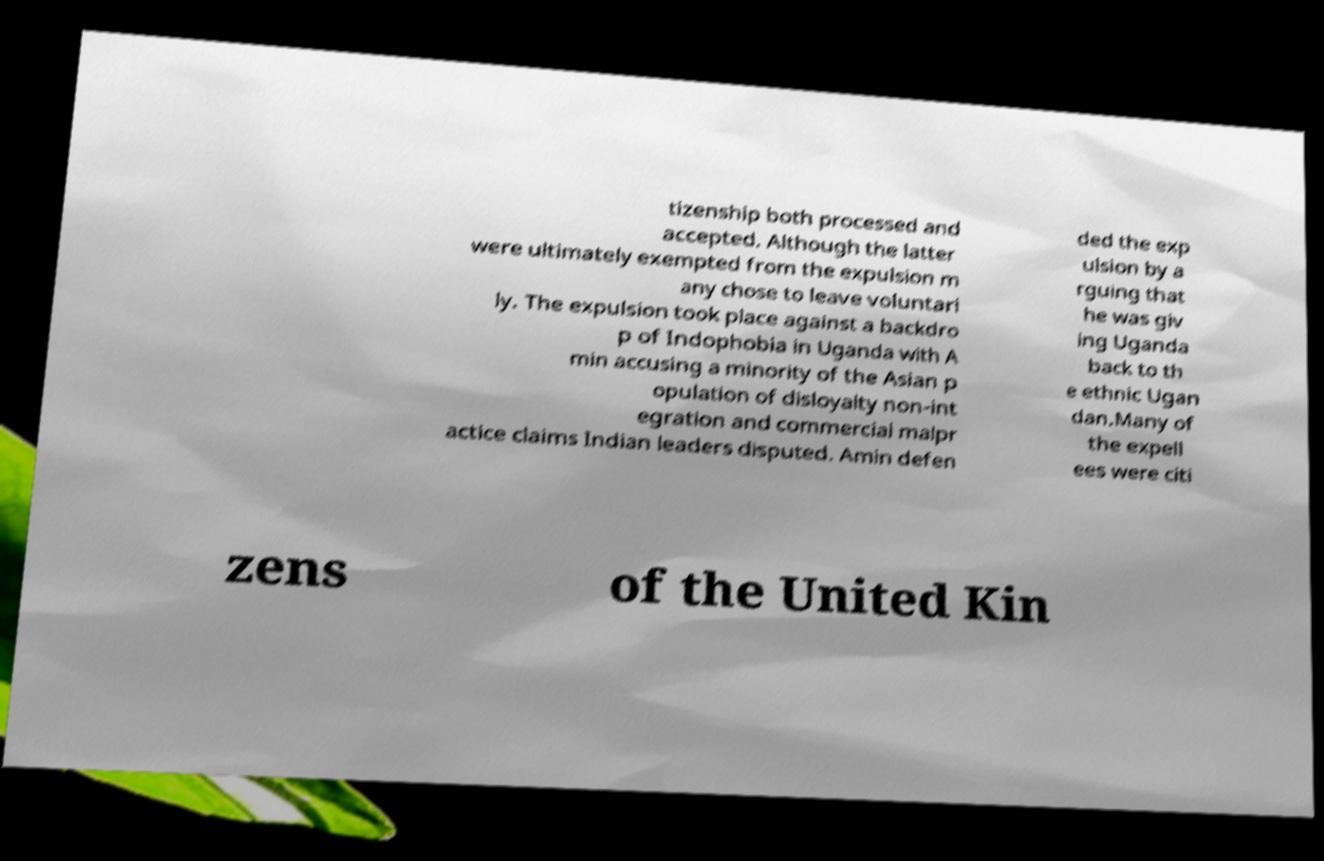I need the written content from this picture converted into text. Can you do that? tizenship both processed and accepted. Although the latter were ultimately exempted from the expulsion m any chose to leave voluntari ly. The expulsion took place against a backdro p of Indophobia in Uganda with A min accusing a minority of the Asian p opulation of disloyalty non-int egration and commercial malpr actice claims Indian leaders disputed. Amin defen ded the exp ulsion by a rguing that he was giv ing Uganda back to th e ethnic Ugan dan.Many of the expell ees were citi zens of the United Kin 